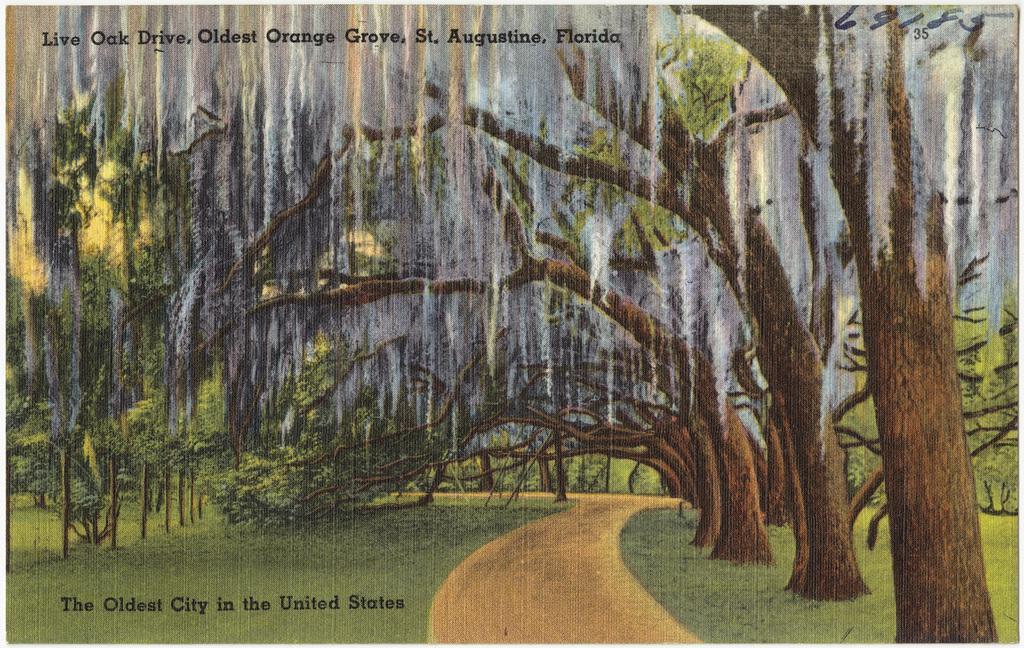Could you give a brief overview of what you see in this image? In this image there is a painting with trees, on the top and bottom of the image there is text and numbers. 